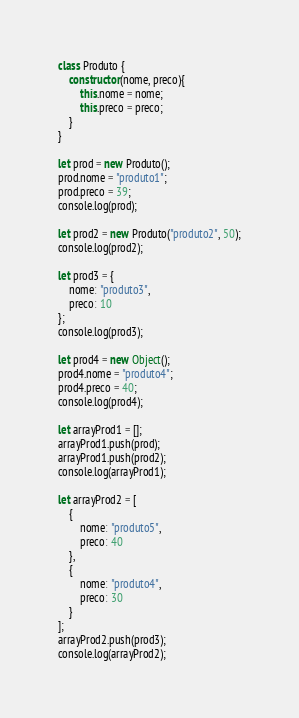Convert code to text. <code><loc_0><loc_0><loc_500><loc_500><_JavaScript_>class Produto {
    constructor(nome, preco){
        this.nome = nome;
        this.preco = preco;
    }
}

let prod = new Produto();
prod.nome = "produto1";
prod.preco = 39;
console.log(prod);

let prod2 = new Produto("produto2", 50);
console.log(prod2);

let prod3 = { 
    nome: "produto3", 
    preco: 10 
};
console.log(prod3);

let prod4 = new Object();
prod4.nome = "produto4";
prod4.preco = 40;
console.log(prod4);

let arrayProd1 = [];
arrayProd1.push(prod);
arrayProd1.push(prod2);
console.log(arrayProd1);

let arrayProd2 = [ 
    { 
        nome: "produto5", 
        preco: 40 
    },
    { 
        nome: "produto4", 
        preco: 30
    }
];
arrayProd2.push(prod3);
console.log(arrayProd2);</code> 